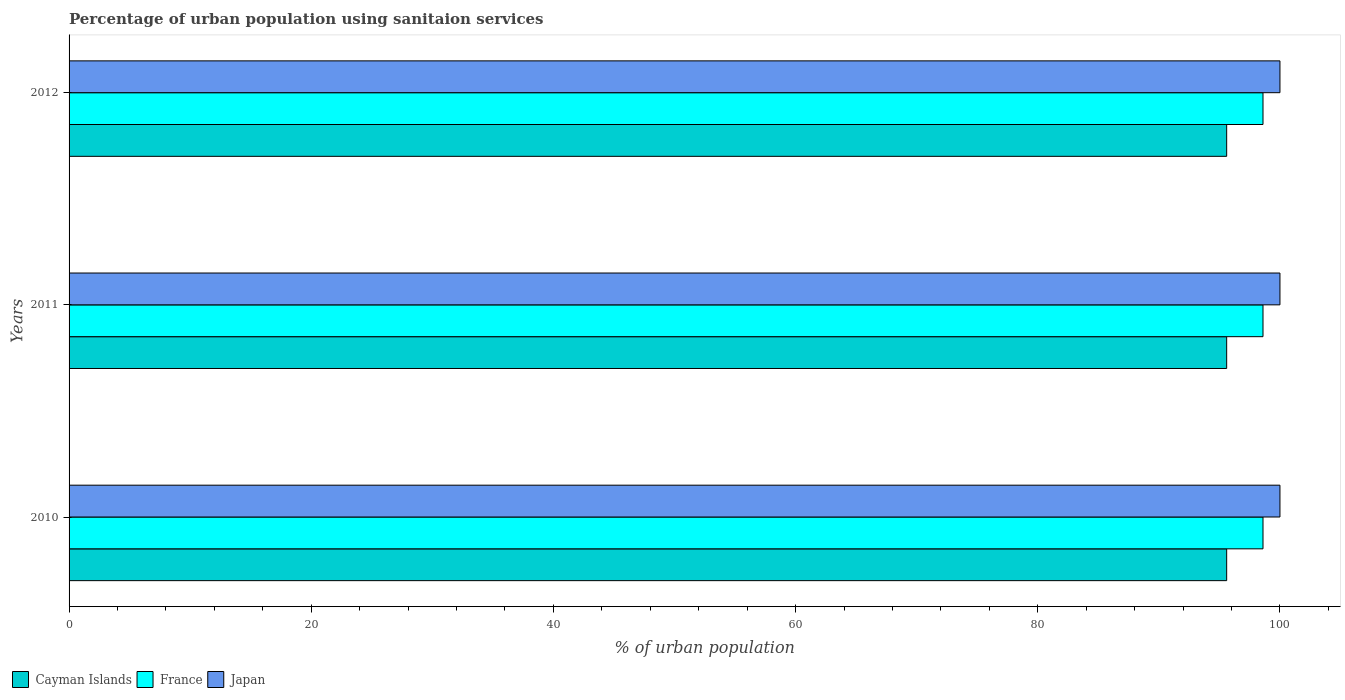How many bars are there on the 3rd tick from the bottom?
Your answer should be compact. 3. What is the percentage of urban population using sanitaion services in Japan in 2012?
Offer a very short reply. 100. Across all years, what is the maximum percentage of urban population using sanitaion services in Japan?
Offer a very short reply. 100. Across all years, what is the minimum percentage of urban population using sanitaion services in Japan?
Your answer should be compact. 100. In which year was the percentage of urban population using sanitaion services in Japan minimum?
Offer a terse response. 2010. What is the total percentage of urban population using sanitaion services in France in the graph?
Your answer should be compact. 295.8. What is the average percentage of urban population using sanitaion services in France per year?
Your response must be concise. 98.6. In the year 2011, what is the difference between the percentage of urban population using sanitaion services in Japan and percentage of urban population using sanitaion services in Cayman Islands?
Give a very brief answer. 4.4. What is the ratio of the percentage of urban population using sanitaion services in Japan in 2010 to that in 2012?
Your answer should be compact. 1. Is the percentage of urban population using sanitaion services in France in 2011 less than that in 2012?
Give a very brief answer. No. What is the difference between the highest and the lowest percentage of urban population using sanitaion services in Cayman Islands?
Ensure brevity in your answer.  0. Is the sum of the percentage of urban population using sanitaion services in France in 2010 and 2011 greater than the maximum percentage of urban population using sanitaion services in Cayman Islands across all years?
Provide a short and direct response. Yes. What does the 2nd bar from the bottom in 2012 represents?
Provide a succinct answer. France. Is it the case that in every year, the sum of the percentage of urban population using sanitaion services in France and percentage of urban population using sanitaion services in Japan is greater than the percentage of urban population using sanitaion services in Cayman Islands?
Provide a short and direct response. Yes. Are all the bars in the graph horizontal?
Provide a short and direct response. Yes. How many years are there in the graph?
Offer a terse response. 3. Are the values on the major ticks of X-axis written in scientific E-notation?
Ensure brevity in your answer.  No. Does the graph contain any zero values?
Your answer should be compact. No. Does the graph contain grids?
Offer a terse response. No. Where does the legend appear in the graph?
Ensure brevity in your answer.  Bottom left. What is the title of the graph?
Your answer should be compact. Percentage of urban population using sanitaion services. Does "Seychelles" appear as one of the legend labels in the graph?
Your response must be concise. No. What is the label or title of the X-axis?
Keep it short and to the point. % of urban population. What is the label or title of the Y-axis?
Provide a succinct answer. Years. What is the % of urban population in Cayman Islands in 2010?
Give a very brief answer. 95.6. What is the % of urban population in France in 2010?
Offer a very short reply. 98.6. What is the % of urban population of Japan in 2010?
Ensure brevity in your answer.  100. What is the % of urban population in Cayman Islands in 2011?
Your answer should be compact. 95.6. What is the % of urban population in France in 2011?
Your answer should be compact. 98.6. What is the % of urban population in Cayman Islands in 2012?
Make the answer very short. 95.6. What is the % of urban population of France in 2012?
Offer a terse response. 98.6. Across all years, what is the maximum % of urban population of Cayman Islands?
Keep it short and to the point. 95.6. Across all years, what is the maximum % of urban population in France?
Your answer should be very brief. 98.6. Across all years, what is the maximum % of urban population of Japan?
Ensure brevity in your answer.  100. Across all years, what is the minimum % of urban population of Cayman Islands?
Your answer should be compact. 95.6. Across all years, what is the minimum % of urban population of France?
Give a very brief answer. 98.6. What is the total % of urban population in Cayman Islands in the graph?
Your response must be concise. 286.8. What is the total % of urban population of France in the graph?
Offer a terse response. 295.8. What is the total % of urban population in Japan in the graph?
Provide a succinct answer. 300. What is the difference between the % of urban population of Japan in 2010 and that in 2011?
Your answer should be compact. 0. What is the difference between the % of urban population of Japan in 2010 and that in 2012?
Ensure brevity in your answer.  0. What is the difference between the % of urban population in Japan in 2011 and that in 2012?
Provide a succinct answer. 0. What is the difference between the % of urban population of Cayman Islands in 2010 and the % of urban population of France in 2011?
Offer a terse response. -3. What is the difference between the % of urban population in France in 2010 and the % of urban population in Japan in 2011?
Keep it short and to the point. -1.4. What is the difference between the % of urban population of Cayman Islands in 2010 and the % of urban population of Japan in 2012?
Keep it short and to the point. -4.4. What is the difference between the % of urban population in France in 2010 and the % of urban population in Japan in 2012?
Your answer should be compact. -1.4. What is the difference between the % of urban population of France in 2011 and the % of urban population of Japan in 2012?
Ensure brevity in your answer.  -1.4. What is the average % of urban population in Cayman Islands per year?
Your answer should be compact. 95.6. What is the average % of urban population in France per year?
Offer a very short reply. 98.6. In the year 2010, what is the difference between the % of urban population of Cayman Islands and % of urban population of France?
Provide a succinct answer. -3. In the year 2010, what is the difference between the % of urban population of Cayman Islands and % of urban population of Japan?
Offer a very short reply. -4.4. In the year 2010, what is the difference between the % of urban population of France and % of urban population of Japan?
Your answer should be compact. -1.4. In the year 2011, what is the difference between the % of urban population in Cayman Islands and % of urban population in Japan?
Make the answer very short. -4.4. In the year 2012, what is the difference between the % of urban population of Cayman Islands and % of urban population of Japan?
Ensure brevity in your answer.  -4.4. What is the ratio of the % of urban population in France in 2010 to that in 2011?
Give a very brief answer. 1. What is the ratio of the % of urban population in Cayman Islands in 2010 to that in 2012?
Provide a short and direct response. 1. What is the ratio of the % of urban population of France in 2010 to that in 2012?
Ensure brevity in your answer.  1. What is the ratio of the % of urban population in Japan in 2010 to that in 2012?
Your response must be concise. 1. What is the ratio of the % of urban population in France in 2011 to that in 2012?
Offer a terse response. 1. What is the ratio of the % of urban population of Japan in 2011 to that in 2012?
Your response must be concise. 1. What is the difference between the highest and the second highest % of urban population in Cayman Islands?
Your answer should be compact. 0. What is the difference between the highest and the second highest % of urban population in Japan?
Your response must be concise. 0. What is the difference between the highest and the lowest % of urban population of Cayman Islands?
Your response must be concise. 0. 